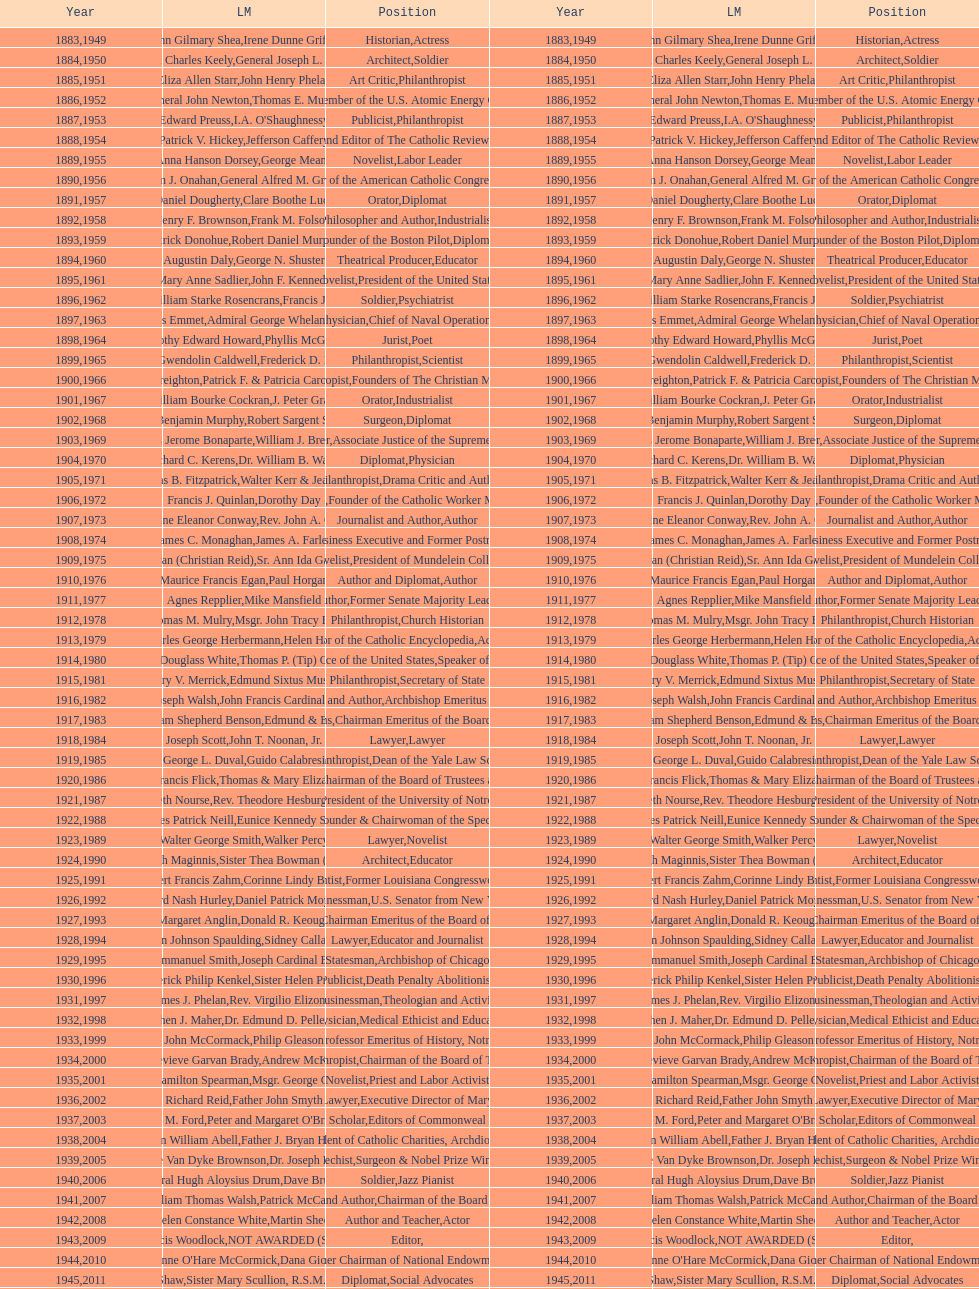Could you help me parse every detail presented in this table? {'header': ['Year', 'LM', 'Position', 'Year', 'LM', 'Position'], 'rows': [['1883', 'John Gilmary Shea', 'Historian', '1949', 'Irene Dunne Griffin', 'Actress'], ['1884', 'Patrick Charles Keely', 'Architect', '1950', 'General Joseph L. Collins', 'Soldier'], ['1885', 'Eliza Allen Starr', 'Art Critic', '1951', 'John Henry Phelan', 'Philanthropist'], ['1886', 'General John Newton', 'Engineer', '1952', 'Thomas E. Murray', 'Member of the U.S. Atomic Energy Commission'], ['1887', 'Edward Preuss', 'Publicist', '1953', "I.A. O'Shaughnessy", 'Philanthropist'], ['1888', 'Patrick V. Hickey', 'Founder and Editor of The Catholic Review', '1954', 'Jefferson Caffery', 'Diplomat'], ['1889', 'Anna Hanson Dorsey', 'Novelist', '1955', 'George Meany', 'Labor Leader'], ['1890', 'William J. Onahan', 'Organizer of the American Catholic Congress', '1956', 'General Alfred M. Gruenther', 'Soldier'], ['1891', 'Daniel Dougherty', 'Orator', '1957', 'Clare Boothe Luce', 'Diplomat'], ['1892', 'Henry F. Brownson', 'Philosopher and Author', '1958', 'Frank M. Folsom', 'Industrialist'], ['1893', 'Patrick Donohue', 'Founder of the Boston Pilot', '1959', 'Robert Daniel Murphy', 'Diplomat'], ['1894', 'Augustin Daly', 'Theatrical Producer', '1960', 'George N. Shuster', 'Educator'], ['1895', 'Mary Anne Sadlier', 'Novelist', '1961', 'John F. Kennedy', 'President of the United States'], ['1896', 'General William Starke Rosencrans', 'Soldier', '1962', 'Francis J. Braceland', 'Psychiatrist'], ['1897', 'Thomas Addis Emmet', 'Physician', '1963', 'Admiral George Whelan Anderson, Jr.', 'Chief of Naval Operations'], ['1898', 'Timothy Edward Howard', 'Jurist', '1964', 'Phyllis McGinley', 'Poet'], ['1899', 'Mary Gwendolin Caldwell', 'Philanthropist', '1965', 'Frederick D. Rossini', 'Scientist'], ['1900', 'John A. Creighton', 'Philanthropist', '1966', 'Patrick F. & Patricia Caron Crowley', 'Founders of The Christian Movement'], ['1901', 'William Bourke Cockran', 'Orator', '1967', 'J. Peter Grace', 'Industrialist'], ['1902', 'John Benjamin Murphy', 'Surgeon', '1968', 'Robert Sargent Shriver', 'Diplomat'], ['1903', 'Charles Jerome Bonaparte', 'Lawyer', '1969', 'William J. Brennan Jr.', 'Associate Justice of the Supreme Court'], ['1904', 'Richard C. Kerens', 'Diplomat', '1970', 'Dr. William B. Walsh', 'Physician'], ['1905', 'Thomas B. Fitzpatrick', 'Philanthropist', '1971', 'Walter Kerr & Jean Kerr', 'Drama Critic and Author'], ['1906', 'Francis J. Quinlan', 'Physician', '1972', 'Dorothy Day', 'Founder of the Catholic Worker Movement'], ['1907', 'Katherine Eleanor Conway', 'Journalist and Author', '1973', "Rev. John A. O'Brien", 'Author'], ['1908', 'James C. Monaghan', 'Economist', '1974', 'James A. Farley', 'Business Executive and Former Postmaster General'], ['1909', 'Frances Tieran (Christian Reid)', 'Novelist', '1975', 'Sr. Ann Ida Gannon, BMV', 'President of Mundelein College'], ['1910', 'Maurice Francis Egan', 'Author and Diplomat', '1976', 'Paul Horgan', 'Author'], ['1911', 'Agnes Repplier', 'Author', '1977', 'Mike Mansfield', 'Former Senate Majority Leader'], ['1912', 'Thomas M. Mulry', 'Philanthropist', '1978', 'Msgr. John Tracy Ellis', 'Church Historian'], ['1913', 'Charles George Herbermann', 'Editor of the Catholic Encyclopedia', '1979', 'Helen Hayes', 'Actress'], ['1914', 'Edward Douglass White', 'Chief Justice of the United States', '1980', "Thomas P. (Tip) O'Neill Jr.", 'Speaker of the House'], ['1915', 'Mary V. Merrick', 'Philanthropist', '1981', 'Edmund Sixtus Muskie', 'Secretary of State'], ['1916', 'James Joseph Walsh', 'Physician and Author', '1982', 'John Francis Cardinal Dearden', 'Archbishop Emeritus of Detroit'], ['1917', 'Admiral William Shepherd Benson', 'Chief of Naval Operations', '1983', 'Edmund & Evelyn Stephan', 'Chairman Emeritus of the Board of Trustees and his wife'], ['1918', 'Joseph Scott', 'Lawyer', '1984', 'John T. Noonan, Jr.', 'Lawyer'], ['1919', 'George L. Duval', 'Philanthropist', '1985', 'Guido Calabresi', 'Dean of the Yale Law School'], ['1920', 'Lawrence Francis Flick', 'Physician', '1986', 'Thomas & Mary Elizabeth Carney', 'Chairman of the Board of Trustees and his wife'], ['1921', 'Elizabeth Nourse', 'Artist', '1987', 'Rev. Theodore Hesburgh, CSC', 'President of the University of Notre Dame'], ['1922', 'Charles Patrick Neill', 'Economist', '1988', 'Eunice Kennedy Shriver', 'Founder & Chairwoman of the Special Olympics'], ['1923', 'Walter George Smith', 'Lawyer', '1989', 'Walker Percy', 'Novelist'], ['1924', 'Charles Donagh Maginnis', 'Architect', '1990', 'Sister Thea Bowman (posthumously)', 'Educator'], ['1925', 'Albert Francis Zahm', 'Scientist', '1991', 'Corinne Lindy Boggs', 'Former Louisiana Congresswoman'], ['1926', 'Edward Nash Hurley', 'Businessman', '1992', 'Daniel Patrick Moynihan', 'U.S. Senator from New York'], ['1927', 'Margaret Anglin', 'Actress', '1993', 'Donald R. Keough', 'Chairman Emeritus of the Board of Trustees'], ['1928', 'John Johnson Spaulding', 'Lawyer', '1994', 'Sidney Callahan', 'Educator and Journalist'], ['1929', 'Alfred Emmanuel Smith', 'Statesman', '1995', 'Joseph Cardinal Bernardin', 'Archbishop of Chicago'], ['1930', 'Frederick Philip Kenkel', 'Publicist', '1996', 'Sister Helen Prejean', 'Death Penalty Abolitionist'], ['1931', 'James J. Phelan', 'Businessman', '1997', 'Rev. Virgilio Elizondo', 'Theologian and Activist'], ['1932', 'Stephen J. Maher', 'Physician', '1998', 'Dr. Edmund D. Pellegrino', 'Medical Ethicist and Educator'], ['1933', 'John McCormack', 'Artist', '1999', 'Philip Gleason', 'Professor Emeritus of History, Notre Dame'], ['1934', 'Genevieve Garvan Brady', 'Philanthropist', '2000', 'Andrew McKenna', 'Chairman of the Board of Trustees'], ['1935', 'Francis Hamilton Spearman', 'Novelist', '2001', 'Msgr. George G. Higgins', 'Priest and Labor Activist'], ['1936', 'Richard Reid', 'Journalist and Lawyer', '2002', 'Father John Smyth', 'Executive Director of Maryville Academy'], ['1937', 'Jeremiah D. M. Ford', 'Scholar', '2003', "Peter and Margaret O'Brien Steinfels", 'Editors of Commonweal'], ['1938', 'Irvin William Abell', 'Surgeon', '2004', 'Father J. Bryan Hehir', 'President of Catholic Charities, Archdiocese of Boston'], ['1939', 'Josephine Van Dyke Brownson', 'Catechist', '2005', 'Dr. Joseph E. Murray', 'Surgeon & Nobel Prize Winner'], ['1940', 'General Hugh Aloysius Drum', 'Soldier', '2006', 'Dave Brubeck', 'Jazz Pianist'], ['1941', 'William Thomas Walsh', 'Journalist and Author', '2007', 'Patrick McCartan', 'Chairman of the Board of Trustees'], ['1942', 'Helen Constance White', 'Author and Teacher', '2008', 'Martin Sheen', 'Actor'], ['1943', 'Thomas Francis Woodlock', 'Editor', '2009', 'NOT AWARDED (SEE BELOW)', ''], ['1944', "Anne O'Hare McCormick", 'Journalist', '2010', 'Dana Gioia', 'Former Chairman of National Endowment for the Arts'], ['1945', 'Gardiner Howland Shaw', 'Diplomat', '2011', 'Sister Mary Scullion, R.S.M., & Joan McConnon', 'Social Advocates'], ['1946', 'Carlton J. H. Hayes', 'Historian and Diplomat', '2012', 'Ken Hackett', 'Former President of Catholic Relief Services'], ['1947', 'William G. Bruce', 'Publisher and Civic Leader', '2013', 'Sister Susanne Gallagher, S.P.\\nSister Mary Therese Harrington, S.H.\\nRev. James H. McCarthy', 'Founders of S.P.R.E.D. (Special Religious Education Development Network)'], ['1948', 'Frank C. Walker', 'Postmaster General and Civic Leader', '2014', 'Kenneth R. Miller', 'Professor of Biology at Brown University']]} How many laetare medalists were philantrohpists? 2. 